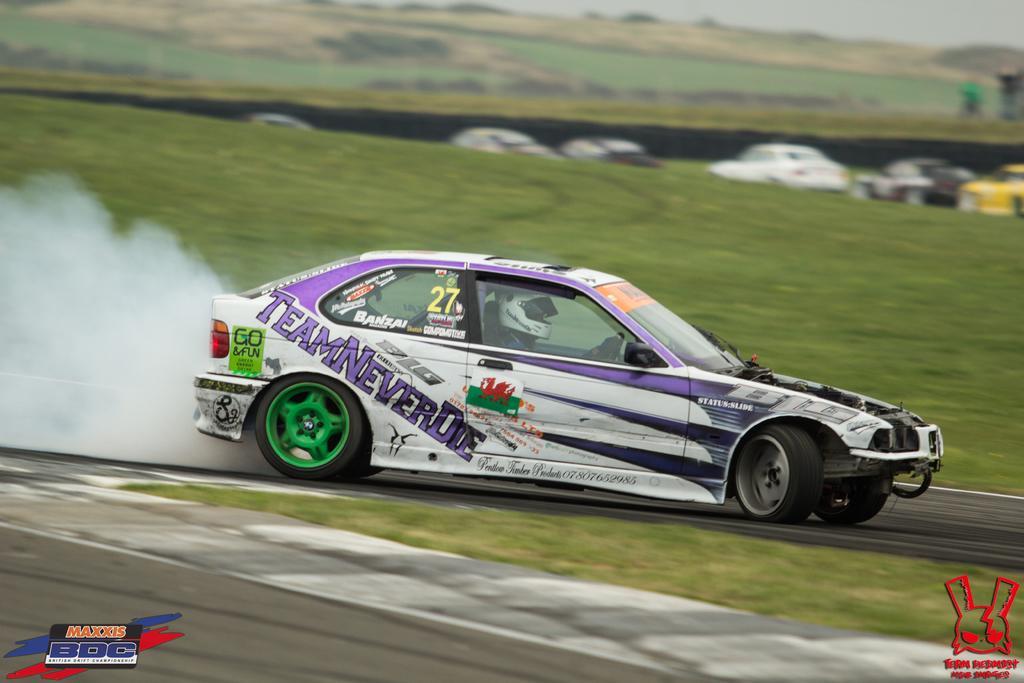In one or two sentences, can you explain what this image depicts? In this image at the bottom we can see road and grass on the ground and there is a person riding a car on the road and behind it we can see the smoke. In the background we can see grass on the ground, vehicles and at the top the image is blur but we can see grass on the ground and sky. 